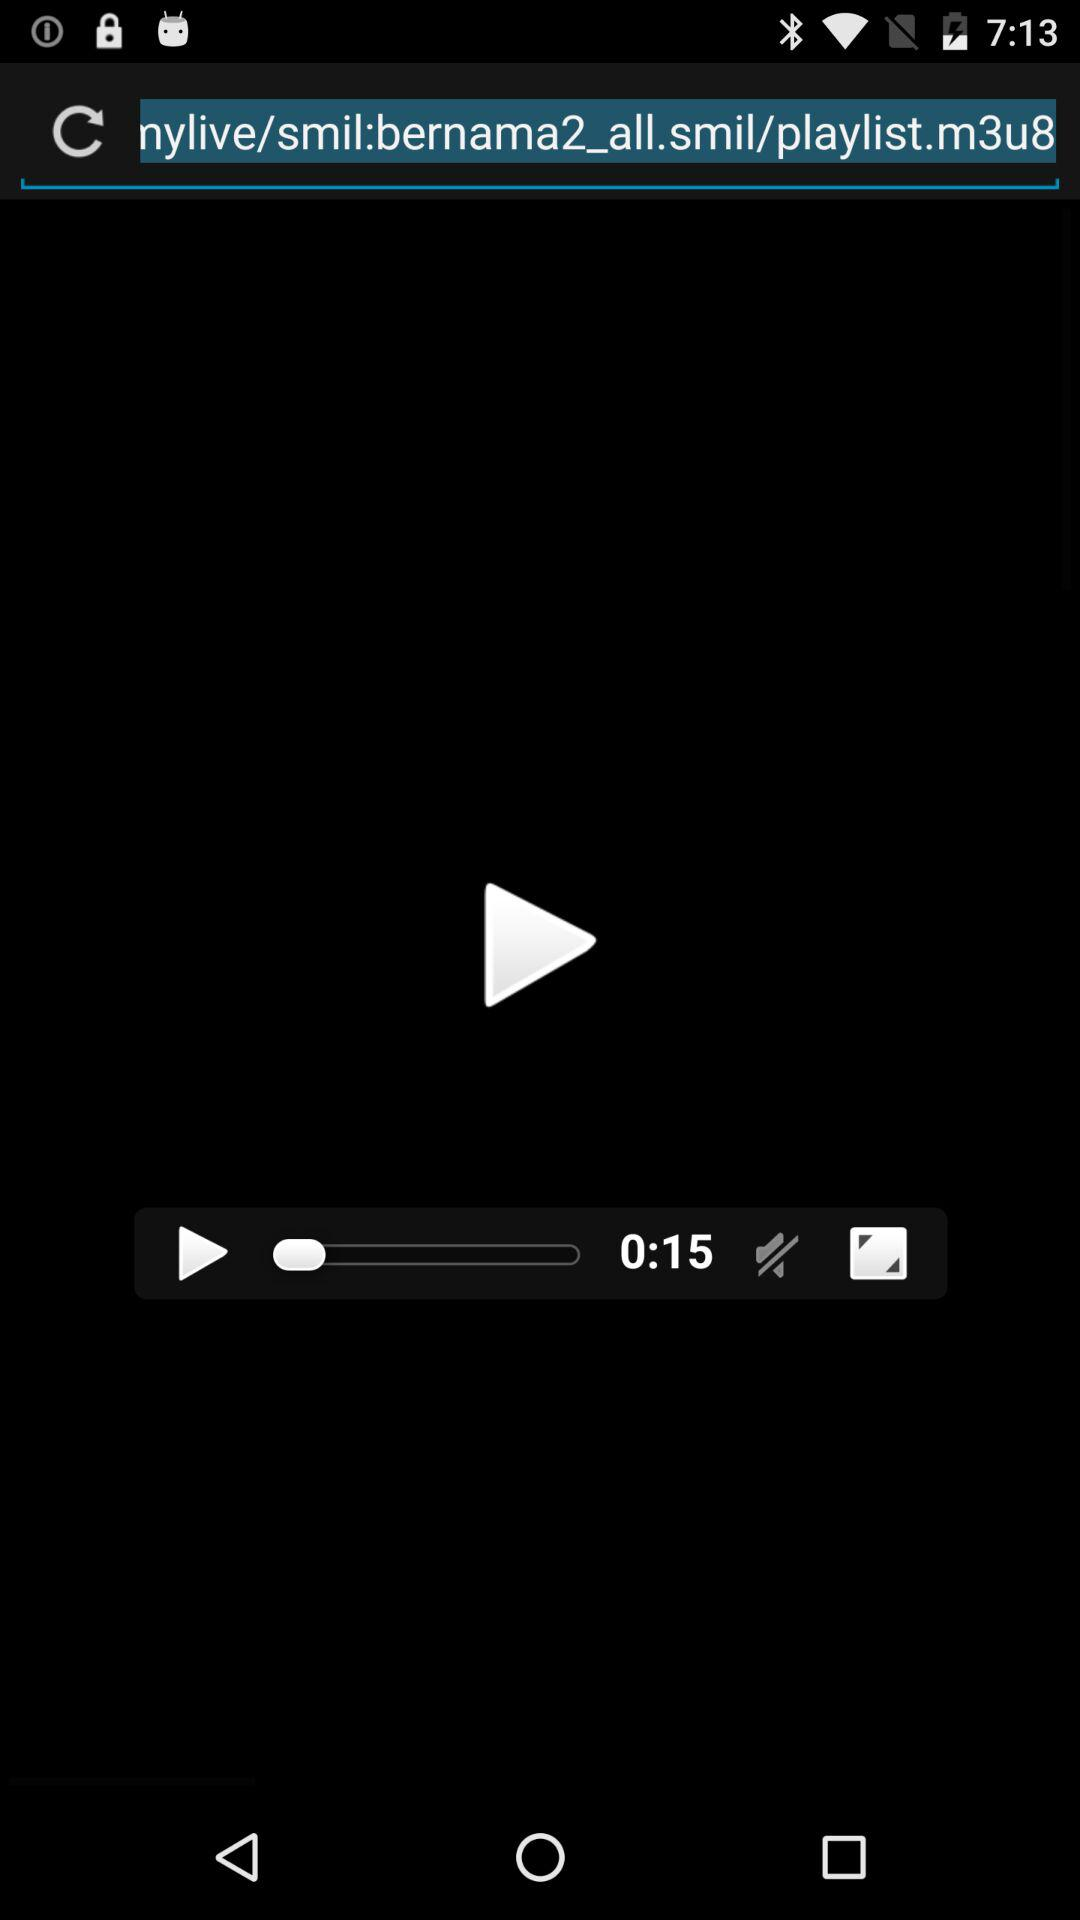What is the title of the video?
When the provided information is insufficient, respond with <no answer>. <no answer> 